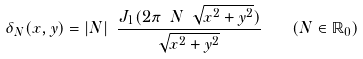<formula> <loc_0><loc_0><loc_500><loc_500>\delta _ { N } ( x , y ) = | N | \ \frac { J _ { 1 } ( 2 \pi \ N \ \sqrt { x ^ { 2 } + y ^ { 2 } } ) } { \sqrt { x ^ { 2 } + y ^ { 2 } } } \quad ( N \in \mathbb { R } _ { 0 } )</formula> 